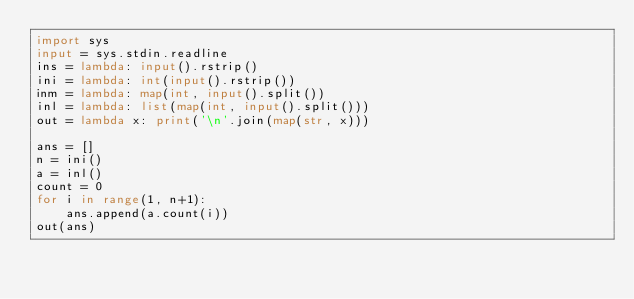<code> <loc_0><loc_0><loc_500><loc_500><_Python_>import sys
input = sys.stdin.readline
ins = lambda: input().rstrip()
ini = lambda: int(input().rstrip())
inm = lambda: map(int, input().split())
inl = lambda: list(map(int, input().split()))
out = lambda x: print('\n'.join(map(str, x)))

ans = []
n = ini()
a = inl()
count = 0
for i in range(1, n+1):
    ans.append(a.count(i))
out(ans)</code> 